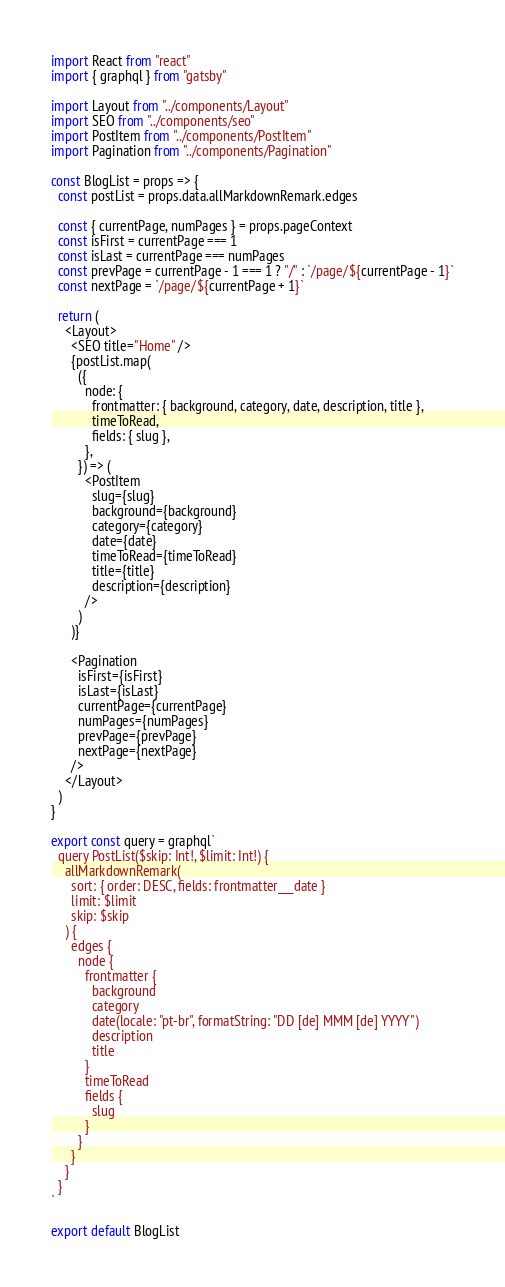<code> <loc_0><loc_0><loc_500><loc_500><_JavaScript_>import React from "react"
import { graphql } from "gatsby"

import Layout from "../components/Layout"
import SEO from "../components/seo"
import PostItem from "../components/PostItem"
import Pagination from "../components/Pagination"

const BlogList = props => {
  const postList = props.data.allMarkdownRemark.edges

  const { currentPage, numPages } = props.pageContext
  const isFirst = currentPage === 1
  const isLast = currentPage === numPages
  const prevPage = currentPage - 1 === 1 ? "/" : `/page/${currentPage - 1}`
  const nextPage = `/page/${currentPage + 1}`

  return (
    <Layout>
      <SEO title="Home" />
      {postList.map(
        ({
          node: {
            frontmatter: { background, category, date, description, title },
            timeToRead,
            fields: { slug },
          },
        }) => (
          <PostItem
            slug={slug}
            background={background}
            category={category}
            date={date}
            timeToRead={timeToRead}
            title={title}
            description={description}
          />
        )
      )}

      <Pagination
        isFirst={isFirst}
        isLast={isLast}
        currentPage={currentPage}
        numPages={numPages}
        prevPage={prevPage}
        nextPage={nextPage}
      />
    </Layout>
  )
}

export const query = graphql`
  query PostList($skip: Int!, $limit: Int!) {
    allMarkdownRemark(
      sort: { order: DESC, fields: frontmatter___date }
      limit: $limit
      skip: $skip
    ) {
      edges {
        node {
          frontmatter {
            background
            category
            date(locale: "pt-br", formatString: "DD [de] MMM [de] YYYY")
            description
            title
          }
          timeToRead
          fields {
            slug
          }
        }
      }
    }
  }
`

export default BlogList
</code> 